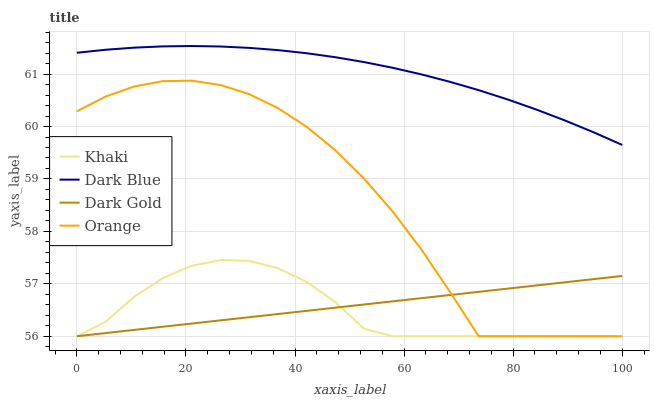Does Khaki have the minimum area under the curve?
Answer yes or no. Yes. Does Dark Blue have the maximum area under the curve?
Answer yes or no. Yes. Does Dark Blue have the minimum area under the curve?
Answer yes or no. No. Does Khaki have the maximum area under the curve?
Answer yes or no. No. Is Dark Gold the smoothest?
Answer yes or no. Yes. Is Orange the roughest?
Answer yes or no. Yes. Is Dark Blue the smoothest?
Answer yes or no. No. Is Dark Blue the roughest?
Answer yes or no. No. Does Orange have the lowest value?
Answer yes or no. Yes. Does Dark Blue have the lowest value?
Answer yes or no. No. Does Dark Blue have the highest value?
Answer yes or no. Yes. Does Khaki have the highest value?
Answer yes or no. No. Is Khaki less than Dark Blue?
Answer yes or no. Yes. Is Dark Blue greater than Khaki?
Answer yes or no. Yes. Does Orange intersect Dark Gold?
Answer yes or no. Yes. Is Orange less than Dark Gold?
Answer yes or no. No. Is Orange greater than Dark Gold?
Answer yes or no. No. Does Khaki intersect Dark Blue?
Answer yes or no. No. 